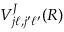Convert formula to latex. <formula><loc_0><loc_0><loc_500><loc_500>V _ { j \ell , j ^ { \prime } \ell ^ { \prime } } ^ { J } ( R )</formula> 